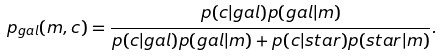Convert formula to latex. <formula><loc_0><loc_0><loc_500><loc_500>p _ { g a l } ( m , { c } ) = \frac { p ( { c } | g a l ) p ( g a l | m ) } { p ( { c } | g a l ) p ( g a l | m ) + p ( { c } | s t a r ) p ( s t a r | m ) } .</formula> 